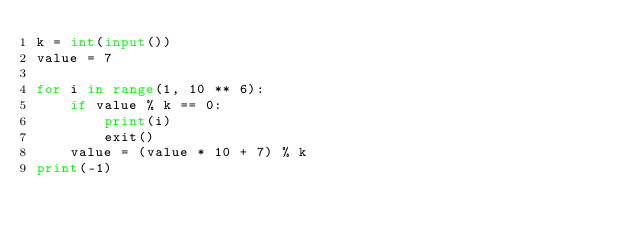Convert code to text. <code><loc_0><loc_0><loc_500><loc_500><_Python_>k = int(input())
value = 7

for i in range(1, 10 ** 6):
    if value % k == 0:
        print(i)
        exit()
    value = (value * 10 + 7) % k
print(-1)</code> 